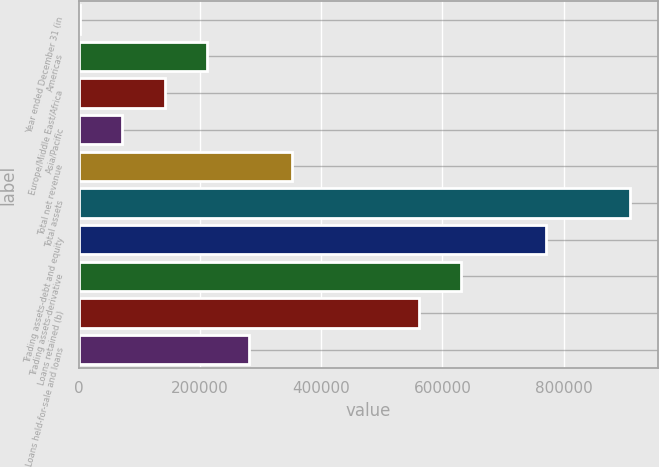Convert chart. <chart><loc_0><loc_0><loc_500><loc_500><bar_chart><fcel>Year ended December 31 (in<fcel>Americas<fcel>Europe/Middle East/Africa<fcel>Asia/Pacific<fcel>Total net revenue<fcel>Total assets<fcel>Trading assets-debt and equity<fcel>Trading assets-derivative<fcel>Loans retained (b)<fcel>Loans held-for-sale and loans<nl><fcel>2007<fcel>211574<fcel>141719<fcel>71862.8<fcel>351286<fcel>910132<fcel>770421<fcel>630709<fcel>560853<fcel>281430<nl></chart> 